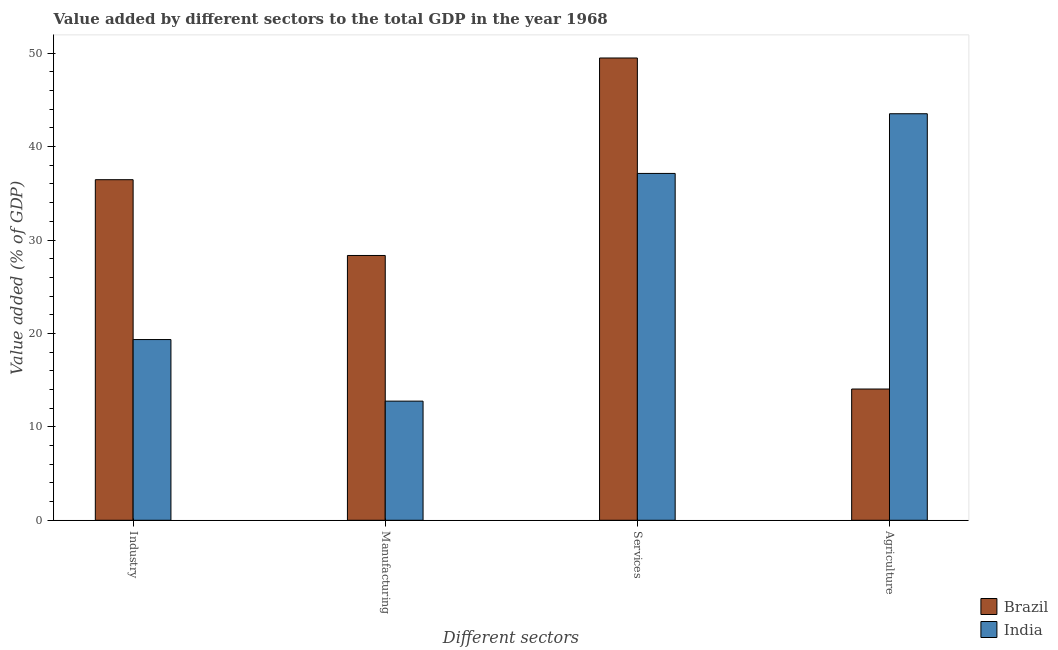How many different coloured bars are there?
Ensure brevity in your answer.  2. How many groups of bars are there?
Offer a terse response. 4. What is the label of the 4th group of bars from the left?
Provide a succinct answer. Agriculture. What is the value added by manufacturing sector in India?
Provide a succinct answer. 12.75. Across all countries, what is the maximum value added by industrial sector?
Offer a terse response. 36.46. Across all countries, what is the minimum value added by industrial sector?
Offer a terse response. 19.35. What is the total value added by agricultural sector in the graph?
Provide a succinct answer. 57.57. What is the difference between the value added by manufacturing sector in India and that in Brazil?
Offer a very short reply. -15.59. What is the difference between the value added by manufacturing sector in Brazil and the value added by services sector in India?
Provide a succinct answer. -8.78. What is the average value added by services sector per country?
Ensure brevity in your answer.  43.31. What is the difference between the value added by manufacturing sector and value added by industrial sector in Brazil?
Provide a succinct answer. -8.11. In how many countries, is the value added by agricultural sector greater than 6 %?
Your answer should be compact. 2. What is the ratio of the value added by manufacturing sector in Brazil to that in India?
Offer a terse response. 2.22. Is the value added by manufacturing sector in Brazil less than that in India?
Your answer should be very brief. No. What is the difference between the highest and the second highest value added by industrial sector?
Your answer should be very brief. 17.11. What is the difference between the highest and the lowest value added by manufacturing sector?
Offer a very short reply. 15.59. In how many countries, is the value added by industrial sector greater than the average value added by industrial sector taken over all countries?
Ensure brevity in your answer.  1. Is the sum of the value added by industrial sector in Brazil and India greater than the maximum value added by agricultural sector across all countries?
Provide a short and direct response. Yes. Is it the case that in every country, the sum of the value added by agricultural sector and value added by industrial sector is greater than the sum of value added by services sector and value added by manufacturing sector?
Your answer should be very brief. No. What does the 2nd bar from the left in Agriculture represents?
Provide a short and direct response. India. What does the 2nd bar from the right in Industry represents?
Give a very brief answer. Brazil. How many countries are there in the graph?
Ensure brevity in your answer.  2. Are the values on the major ticks of Y-axis written in scientific E-notation?
Provide a short and direct response. No. How are the legend labels stacked?
Offer a terse response. Vertical. What is the title of the graph?
Your answer should be compact. Value added by different sectors to the total GDP in the year 1968. What is the label or title of the X-axis?
Give a very brief answer. Different sectors. What is the label or title of the Y-axis?
Your response must be concise. Value added (% of GDP). What is the Value added (% of GDP) of Brazil in Industry?
Make the answer very short. 36.46. What is the Value added (% of GDP) in India in Industry?
Provide a short and direct response. 19.35. What is the Value added (% of GDP) of Brazil in Manufacturing?
Make the answer very short. 28.35. What is the Value added (% of GDP) of India in Manufacturing?
Offer a very short reply. 12.75. What is the Value added (% of GDP) in Brazil in Services?
Give a very brief answer. 49.49. What is the Value added (% of GDP) of India in Services?
Offer a terse response. 37.13. What is the Value added (% of GDP) in Brazil in Agriculture?
Make the answer very short. 14.05. What is the Value added (% of GDP) in India in Agriculture?
Ensure brevity in your answer.  43.52. Across all Different sectors, what is the maximum Value added (% of GDP) of Brazil?
Your answer should be very brief. 49.49. Across all Different sectors, what is the maximum Value added (% of GDP) of India?
Provide a short and direct response. 43.52. Across all Different sectors, what is the minimum Value added (% of GDP) in Brazil?
Your answer should be very brief. 14.05. Across all Different sectors, what is the minimum Value added (% of GDP) in India?
Your answer should be very brief. 12.75. What is the total Value added (% of GDP) in Brazil in the graph?
Provide a short and direct response. 128.35. What is the total Value added (% of GDP) of India in the graph?
Offer a terse response. 112.75. What is the difference between the Value added (% of GDP) of Brazil in Industry and that in Manufacturing?
Your response must be concise. 8.11. What is the difference between the Value added (% of GDP) in India in Industry and that in Manufacturing?
Make the answer very short. 6.59. What is the difference between the Value added (% of GDP) in Brazil in Industry and that in Services?
Offer a terse response. -13.03. What is the difference between the Value added (% of GDP) in India in Industry and that in Services?
Ensure brevity in your answer.  -17.78. What is the difference between the Value added (% of GDP) in Brazil in Industry and that in Agriculture?
Offer a very short reply. 22.41. What is the difference between the Value added (% of GDP) in India in Industry and that in Agriculture?
Provide a short and direct response. -24.17. What is the difference between the Value added (% of GDP) of Brazil in Manufacturing and that in Services?
Ensure brevity in your answer.  -21.14. What is the difference between the Value added (% of GDP) of India in Manufacturing and that in Services?
Your answer should be very brief. -24.38. What is the difference between the Value added (% of GDP) in Brazil in Manufacturing and that in Agriculture?
Make the answer very short. 14.3. What is the difference between the Value added (% of GDP) in India in Manufacturing and that in Agriculture?
Provide a succinct answer. -30.77. What is the difference between the Value added (% of GDP) in Brazil in Services and that in Agriculture?
Give a very brief answer. 35.44. What is the difference between the Value added (% of GDP) of India in Services and that in Agriculture?
Ensure brevity in your answer.  -6.39. What is the difference between the Value added (% of GDP) in Brazil in Industry and the Value added (% of GDP) in India in Manufacturing?
Your response must be concise. 23.71. What is the difference between the Value added (% of GDP) of Brazil in Industry and the Value added (% of GDP) of India in Services?
Your answer should be compact. -0.67. What is the difference between the Value added (% of GDP) of Brazil in Industry and the Value added (% of GDP) of India in Agriculture?
Keep it short and to the point. -7.06. What is the difference between the Value added (% of GDP) in Brazil in Manufacturing and the Value added (% of GDP) in India in Services?
Provide a short and direct response. -8.78. What is the difference between the Value added (% of GDP) of Brazil in Manufacturing and the Value added (% of GDP) of India in Agriculture?
Your answer should be very brief. -15.17. What is the difference between the Value added (% of GDP) of Brazil in Services and the Value added (% of GDP) of India in Agriculture?
Your answer should be very brief. 5.97. What is the average Value added (% of GDP) in Brazil per Different sectors?
Keep it short and to the point. 32.09. What is the average Value added (% of GDP) of India per Different sectors?
Give a very brief answer. 28.19. What is the difference between the Value added (% of GDP) in Brazil and Value added (% of GDP) in India in Industry?
Provide a succinct answer. 17.11. What is the difference between the Value added (% of GDP) of Brazil and Value added (% of GDP) of India in Manufacturing?
Make the answer very short. 15.59. What is the difference between the Value added (% of GDP) in Brazil and Value added (% of GDP) in India in Services?
Keep it short and to the point. 12.36. What is the difference between the Value added (% of GDP) of Brazil and Value added (% of GDP) of India in Agriculture?
Give a very brief answer. -29.47. What is the ratio of the Value added (% of GDP) of Brazil in Industry to that in Manufacturing?
Your response must be concise. 1.29. What is the ratio of the Value added (% of GDP) of India in Industry to that in Manufacturing?
Give a very brief answer. 1.52. What is the ratio of the Value added (% of GDP) of Brazil in Industry to that in Services?
Give a very brief answer. 0.74. What is the ratio of the Value added (% of GDP) in India in Industry to that in Services?
Offer a very short reply. 0.52. What is the ratio of the Value added (% of GDP) of Brazil in Industry to that in Agriculture?
Offer a very short reply. 2.59. What is the ratio of the Value added (% of GDP) in India in Industry to that in Agriculture?
Ensure brevity in your answer.  0.44. What is the ratio of the Value added (% of GDP) of Brazil in Manufacturing to that in Services?
Provide a short and direct response. 0.57. What is the ratio of the Value added (% of GDP) in India in Manufacturing to that in Services?
Offer a terse response. 0.34. What is the ratio of the Value added (% of GDP) in Brazil in Manufacturing to that in Agriculture?
Provide a succinct answer. 2.02. What is the ratio of the Value added (% of GDP) of India in Manufacturing to that in Agriculture?
Keep it short and to the point. 0.29. What is the ratio of the Value added (% of GDP) in Brazil in Services to that in Agriculture?
Your answer should be compact. 3.52. What is the ratio of the Value added (% of GDP) of India in Services to that in Agriculture?
Keep it short and to the point. 0.85. What is the difference between the highest and the second highest Value added (% of GDP) in Brazil?
Ensure brevity in your answer.  13.03. What is the difference between the highest and the second highest Value added (% of GDP) in India?
Offer a very short reply. 6.39. What is the difference between the highest and the lowest Value added (% of GDP) in Brazil?
Your response must be concise. 35.44. What is the difference between the highest and the lowest Value added (% of GDP) of India?
Ensure brevity in your answer.  30.77. 